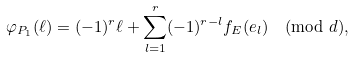<formula> <loc_0><loc_0><loc_500><loc_500>\varphi _ { P _ { 1 } } ( \ell ) = ( - 1 ) ^ { r } \ell + \sum _ { l = 1 } ^ { r } ( - 1 ) ^ { r - l } f _ { E } ( e _ { l } ) \pmod { d } ,</formula> 